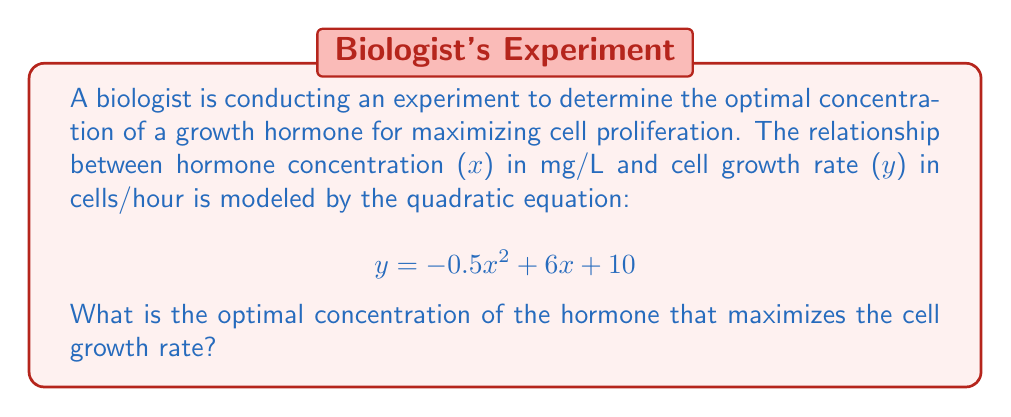What is the answer to this math problem? To find the optimal concentration, we need to determine the vertex of the parabola described by the quadratic equation. The vertex represents the maximum point of the parabola, which corresponds to the optimal concentration.

For a quadratic equation in the form $y = ax^2 + bx + c$, the x-coordinate of the vertex is given by $x = -\frac{b}{2a}$.

In this case:
$a = -0.5$
$b = 6$
$c = 10$

Substituting these values into the formula:

$$ x = -\frac{6}{2(-0.5)} = -\frac{6}{-1} = 6 $$

To verify this result and find the maximum growth rate, we can substitute x = 6 back into the original equation:

$$ y = -0.5(6)^2 + 6(6) + 10 $$
$$ y = -0.5(36) + 36 + 10 $$
$$ y = -18 + 36 + 10 $$
$$ y = 28 $$

This confirms that the maximum growth rate occurs at x = 6 mg/L.
Answer: The optimal concentration of the hormone is 6 mg/L. 